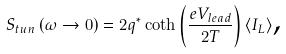<formula> <loc_0><loc_0><loc_500><loc_500>S _ { t u n } \left ( \omega \rightarrow 0 \right ) = 2 q ^ { \ast } \coth \left ( \frac { e V _ { l e a d } } { 2 T } \right ) \langle I _ { L } \rangle \text {,}</formula> 